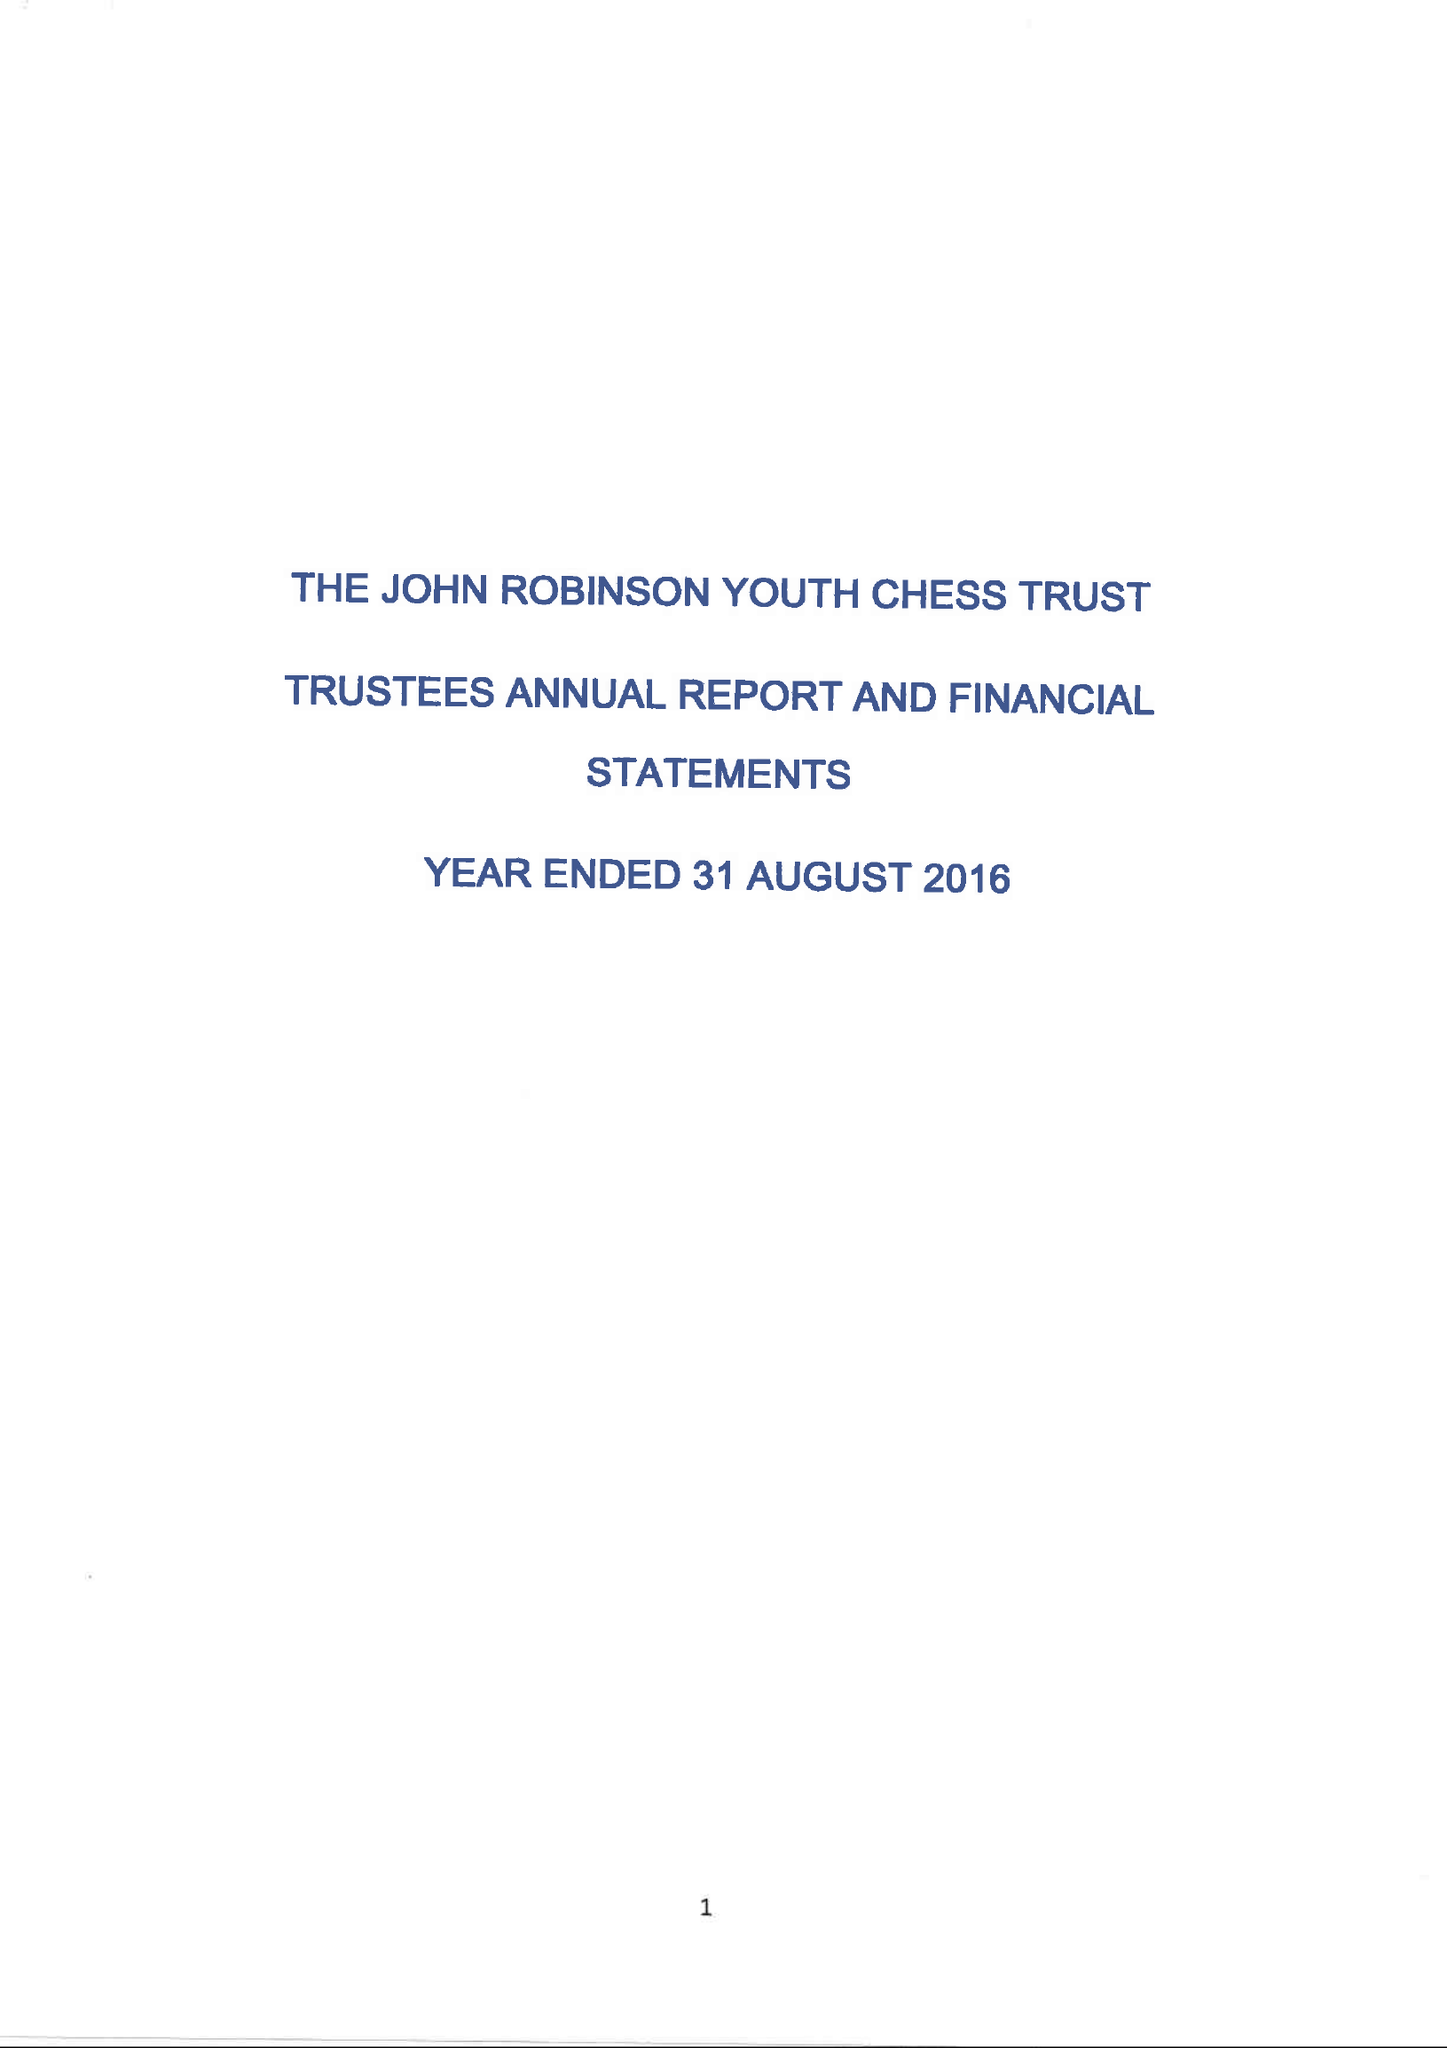What is the value for the charity_name?
Answer the question using a single word or phrase. The John Robinson Youth Chess Trust 